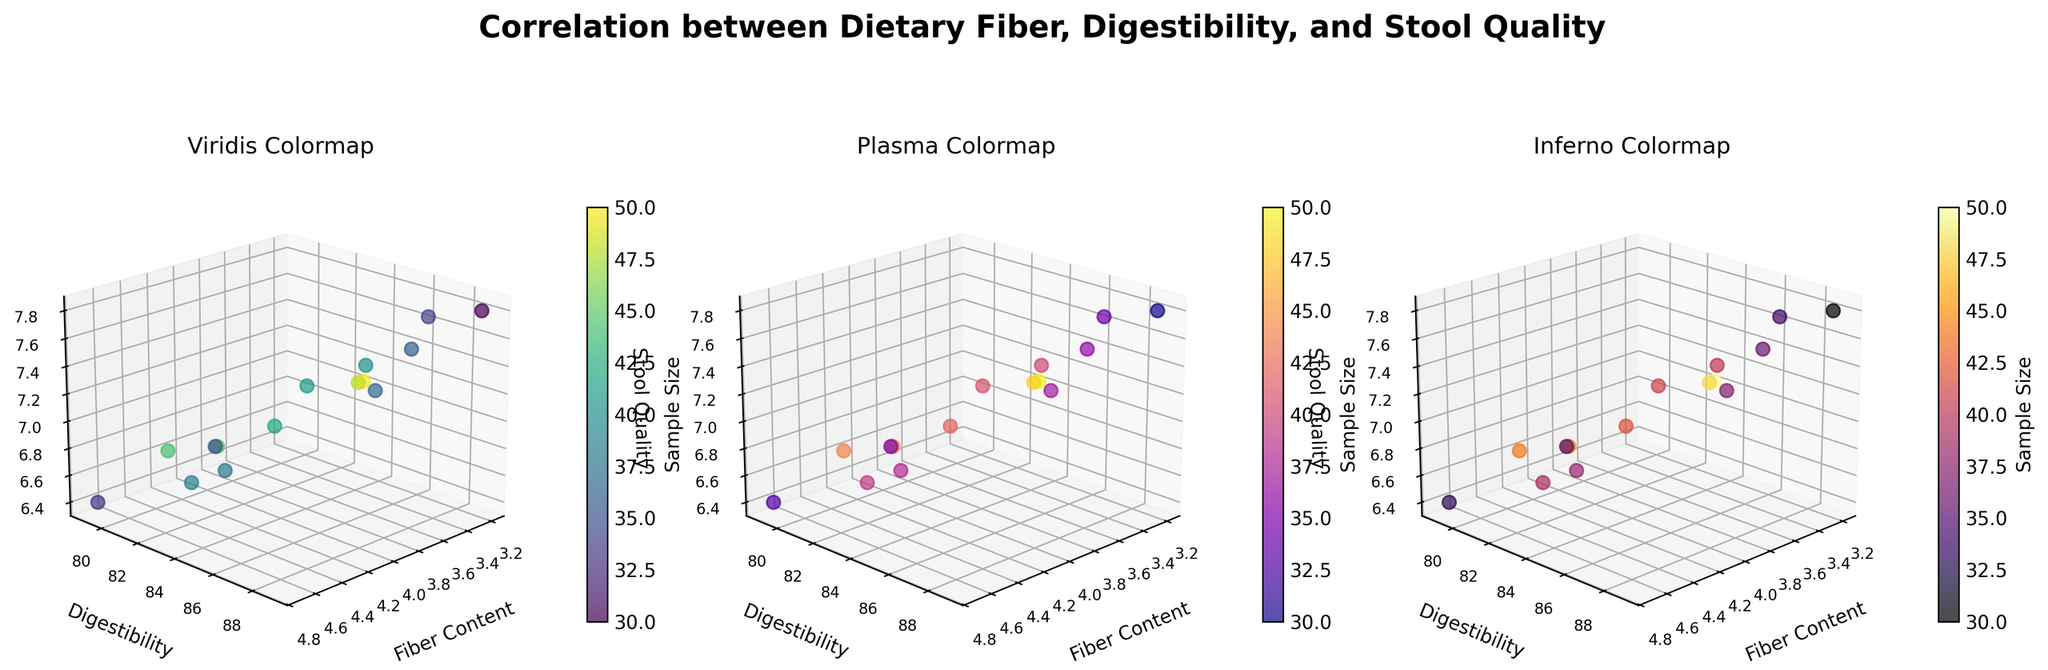What is the title of the figure? The main title of the figure is written at the top and reads 'Correlation between Dietary Fiber, Digestibility, and Stool Quality'. This can be found above the subplots.
Answer: Correlation between Dietary Fiber, Digestibility, and Stool Quality What are the labels of the axes in the subplots? The labels for the x-axis, y-axis, and z-axis in all subplots are the same and labeled as 'Fiber Content', 'Digestibility', and 'Stool Quality' respectively.
Answer: Fiber Content, Digestibility, Stool Quality Which breed has the highest stool quality? By looking at the z-axis (Stool Quality) in the subplots, we can see that the Chihuahua has the highest stool quality value of 7.8.
Answer: Chihuahua How is sample size represented visually in the subplots? Sample size is represented by the color of the data points. Each subplot uses a different colormap.
Answer: By color Between Labrador Retriever and German Shepherd, which breed has higher digestibility? Referring to the y-axis (Digestibility) in the subplots, the Labrador Retriever has a digestibility of 85, while the German Shepherd has a digestibility of 82. Therefore, Labrador Retriever has higher digestibility.
Answer: Labrador Retriever What is the stool quality of the breed with the highest fiber content? The breed with the highest fiber content is the Great Dane with 4.7. Its stool quality, based on the z-axis, is 6.4.
Answer: 6.4 Which breed has both high digestibility and high stool quality based on the figure? The Beagle and Chihuahua stand out as having both high digestibility (87 and 89 respectively) and high stool quality (7.5 and 7.8 respectively) based on the subplots.
Answer: Beagle, Chihuahua Compare the stool quality of German Shepherd and Boxer. Which breed has better stool quality? Based on the z-axis for stool quality, the German Shepherd has a stool quality of 6.8, and the Boxer has a stool quality of 6.9. Boxer has a marginally better stool quality.
Answer: Boxer Is there a general trend between fiber content and digestibility across different breeds? By observing the plots, it appears that there is no strong visible trend between fiber content and digestibility across different breeds, as the points are scattered without a clear pattern in the 3D space.
Answer: No clear trend What are the three colormaps used in the subplots? The subplot on the left uses 'Viridis', the middle one uses 'Plasma', and the one on the right uses 'Inferno' colormap.
Answer: Viridis, Plasma, Inferno 